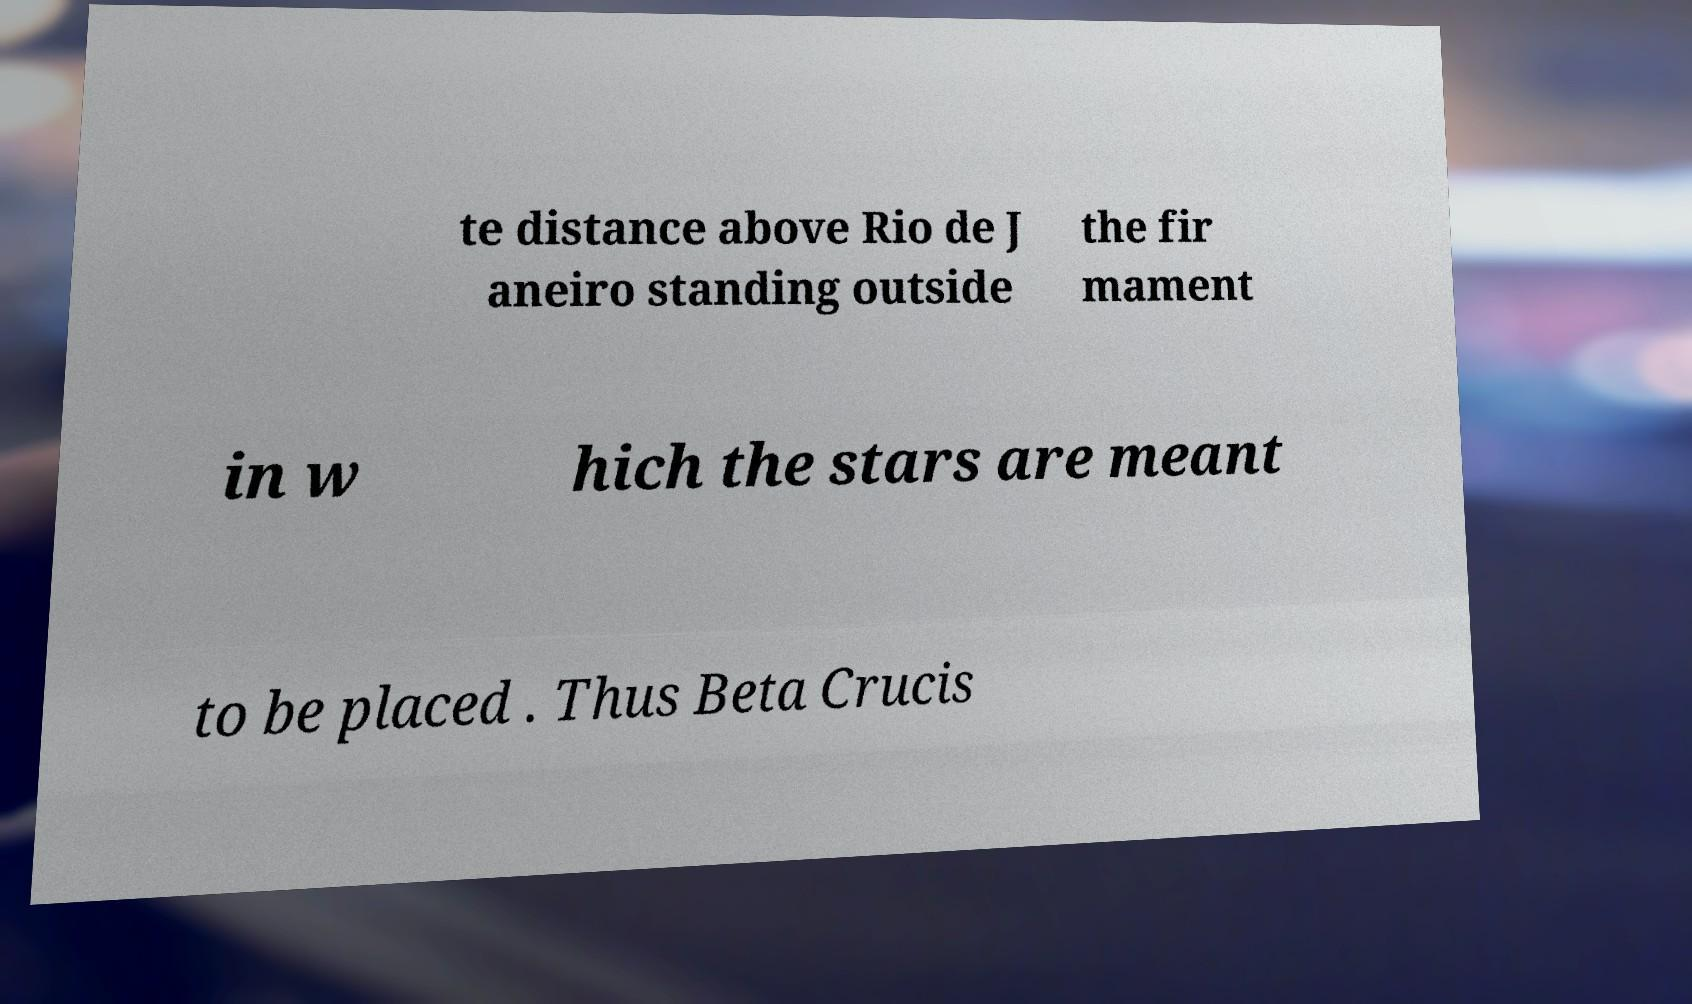Can you accurately transcribe the text from the provided image for me? te distance above Rio de J aneiro standing outside the fir mament in w hich the stars are meant to be placed . Thus Beta Crucis 